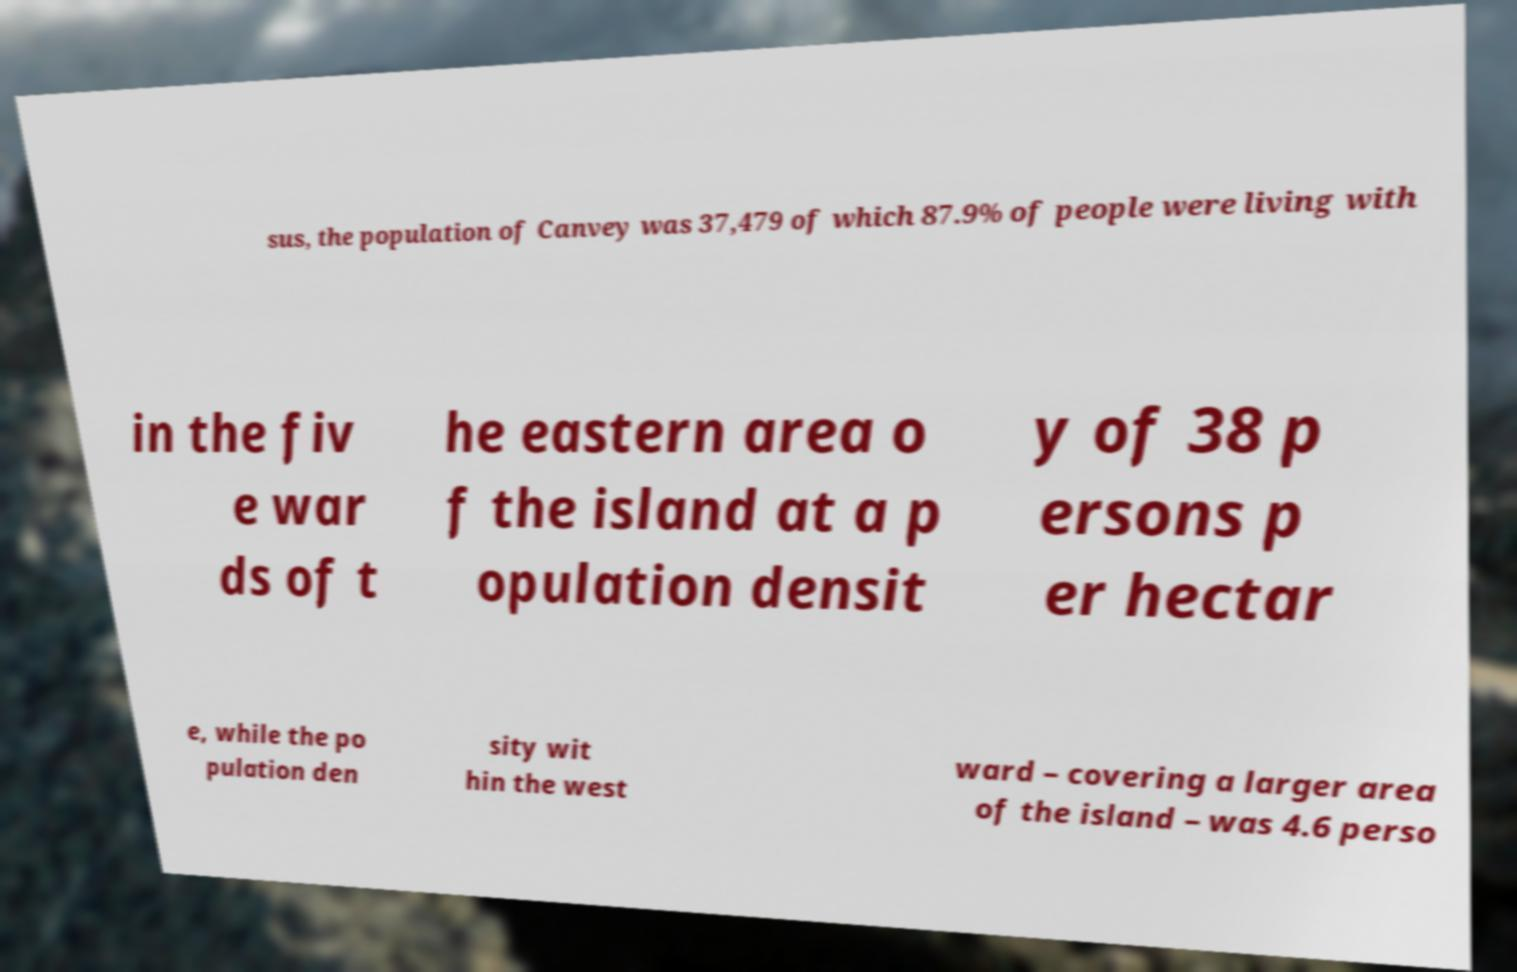There's text embedded in this image that I need extracted. Can you transcribe it verbatim? sus, the population of Canvey was 37,479 of which 87.9% of people were living with in the fiv e war ds of t he eastern area o f the island at a p opulation densit y of 38 p ersons p er hectar e, while the po pulation den sity wit hin the west ward – covering a larger area of the island – was 4.6 perso 